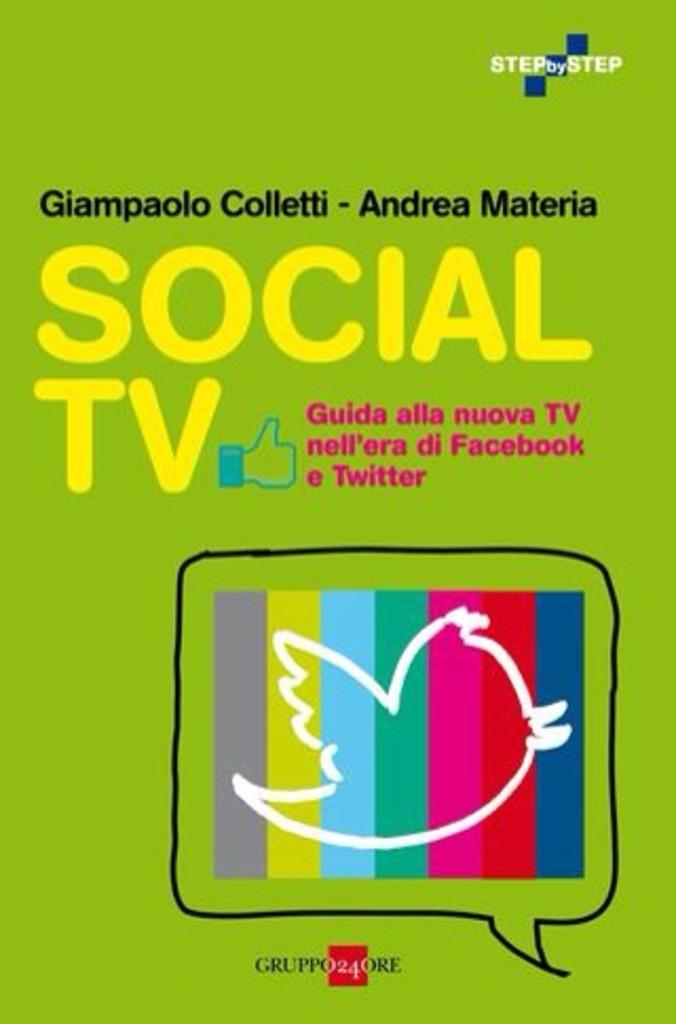What is the title of this book?
Offer a terse response. Social tv. This social tv?
Your response must be concise. Yes. 